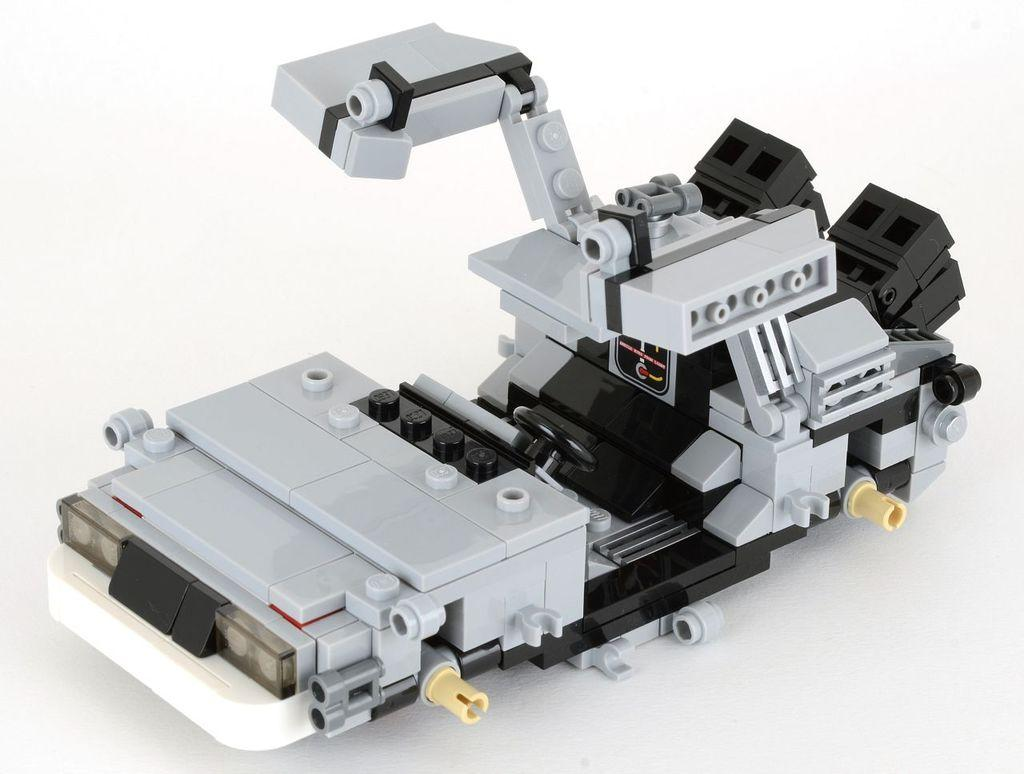What is the color and design of the object in the image? The object in the image is silver and black. What is the object placed on in the image? The object is on a white surface. How many kitties are playing with a chain on the brick wall in the image? There are no kitties, chains, or brick walls present in the image. 